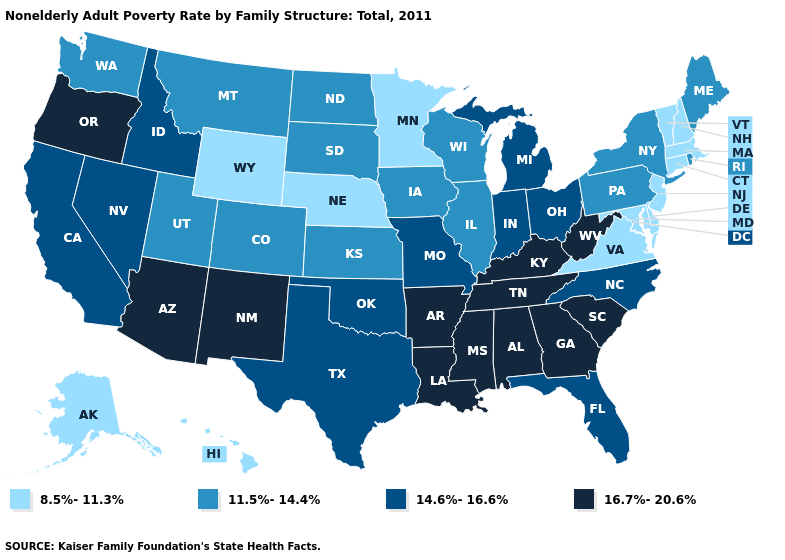Name the states that have a value in the range 8.5%-11.3%?
Give a very brief answer. Alaska, Connecticut, Delaware, Hawaii, Maryland, Massachusetts, Minnesota, Nebraska, New Hampshire, New Jersey, Vermont, Virginia, Wyoming. Does New Mexico have a higher value than Massachusetts?
Short answer required. Yes. What is the lowest value in the USA?
Keep it brief. 8.5%-11.3%. Among the states that border Maryland , which have the highest value?
Keep it brief. West Virginia. Among the states that border New Jersey , does New York have the lowest value?
Concise answer only. No. What is the value of Georgia?
Quick response, please. 16.7%-20.6%. What is the value of Arizona?
Be succinct. 16.7%-20.6%. What is the highest value in states that border West Virginia?
Keep it brief. 16.7%-20.6%. Name the states that have a value in the range 11.5%-14.4%?
Concise answer only. Colorado, Illinois, Iowa, Kansas, Maine, Montana, New York, North Dakota, Pennsylvania, Rhode Island, South Dakota, Utah, Washington, Wisconsin. What is the value of Nevada?
Short answer required. 14.6%-16.6%. Does New Hampshire have a higher value than Rhode Island?
Quick response, please. No. Does Michigan have a higher value than Rhode Island?
Short answer required. Yes. Does West Virginia have the lowest value in the USA?
Concise answer only. No. Does the map have missing data?
Write a very short answer. No. Does New Hampshire have the lowest value in the USA?
Write a very short answer. Yes. 